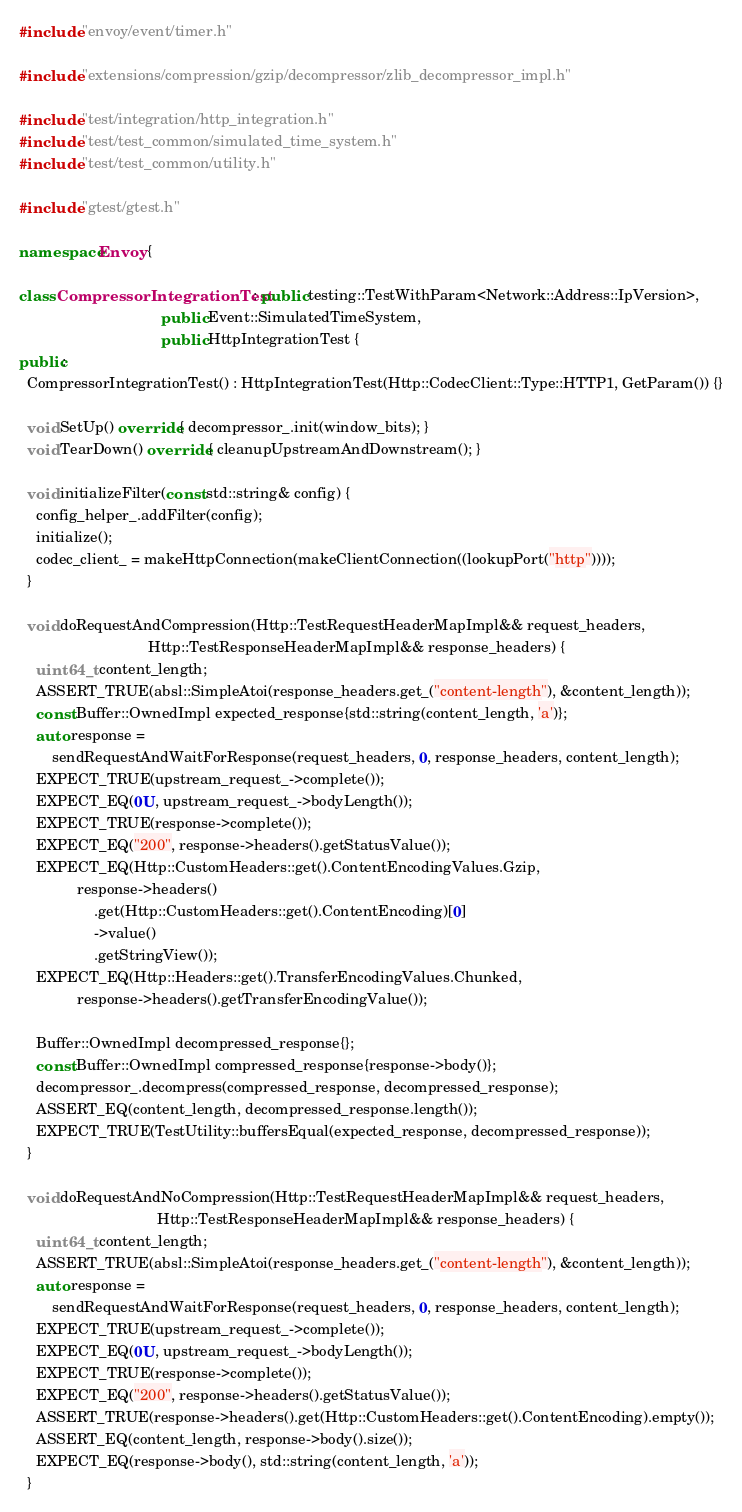<code> <loc_0><loc_0><loc_500><loc_500><_C++_>#include "envoy/event/timer.h"

#include "extensions/compression/gzip/decompressor/zlib_decompressor_impl.h"

#include "test/integration/http_integration.h"
#include "test/test_common/simulated_time_system.h"
#include "test/test_common/utility.h"

#include "gtest/gtest.h"

namespace Envoy {

class CompressorIntegrationTest : public testing::TestWithParam<Network::Address::IpVersion>,
                                  public Event::SimulatedTimeSystem,
                                  public HttpIntegrationTest {
public:
  CompressorIntegrationTest() : HttpIntegrationTest(Http::CodecClient::Type::HTTP1, GetParam()) {}

  void SetUp() override { decompressor_.init(window_bits); }
  void TearDown() override { cleanupUpstreamAndDownstream(); }

  void initializeFilter(const std::string& config) {
    config_helper_.addFilter(config);
    initialize();
    codec_client_ = makeHttpConnection(makeClientConnection((lookupPort("http"))));
  }

  void doRequestAndCompression(Http::TestRequestHeaderMapImpl&& request_headers,
                               Http::TestResponseHeaderMapImpl&& response_headers) {
    uint64_t content_length;
    ASSERT_TRUE(absl::SimpleAtoi(response_headers.get_("content-length"), &content_length));
    const Buffer::OwnedImpl expected_response{std::string(content_length, 'a')};
    auto response =
        sendRequestAndWaitForResponse(request_headers, 0, response_headers, content_length);
    EXPECT_TRUE(upstream_request_->complete());
    EXPECT_EQ(0U, upstream_request_->bodyLength());
    EXPECT_TRUE(response->complete());
    EXPECT_EQ("200", response->headers().getStatusValue());
    EXPECT_EQ(Http::CustomHeaders::get().ContentEncodingValues.Gzip,
              response->headers()
                  .get(Http::CustomHeaders::get().ContentEncoding)[0]
                  ->value()
                  .getStringView());
    EXPECT_EQ(Http::Headers::get().TransferEncodingValues.Chunked,
              response->headers().getTransferEncodingValue());

    Buffer::OwnedImpl decompressed_response{};
    const Buffer::OwnedImpl compressed_response{response->body()};
    decompressor_.decompress(compressed_response, decompressed_response);
    ASSERT_EQ(content_length, decompressed_response.length());
    EXPECT_TRUE(TestUtility::buffersEqual(expected_response, decompressed_response));
  }

  void doRequestAndNoCompression(Http::TestRequestHeaderMapImpl&& request_headers,
                                 Http::TestResponseHeaderMapImpl&& response_headers) {
    uint64_t content_length;
    ASSERT_TRUE(absl::SimpleAtoi(response_headers.get_("content-length"), &content_length));
    auto response =
        sendRequestAndWaitForResponse(request_headers, 0, response_headers, content_length);
    EXPECT_TRUE(upstream_request_->complete());
    EXPECT_EQ(0U, upstream_request_->bodyLength());
    EXPECT_TRUE(response->complete());
    EXPECT_EQ("200", response->headers().getStatusValue());
    ASSERT_TRUE(response->headers().get(Http::CustomHeaders::get().ContentEncoding).empty());
    ASSERT_EQ(content_length, response->body().size());
    EXPECT_EQ(response->body(), std::string(content_length, 'a'));
  }
</code> 